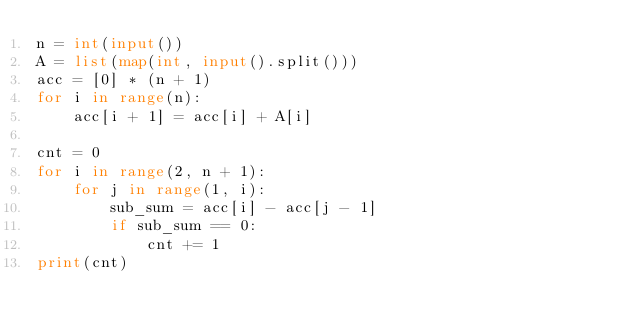Convert code to text. <code><loc_0><loc_0><loc_500><loc_500><_Python_>n = int(input())
A = list(map(int, input().split()))
acc = [0] * (n + 1)
for i in range(n):
    acc[i + 1] = acc[i] + A[i]

cnt = 0
for i in range(2, n + 1):
    for j in range(1, i):
        sub_sum = acc[i] - acc[j - 1]
        if sub_sum == 0:
            cnt += 1
print(cnt)</code> 